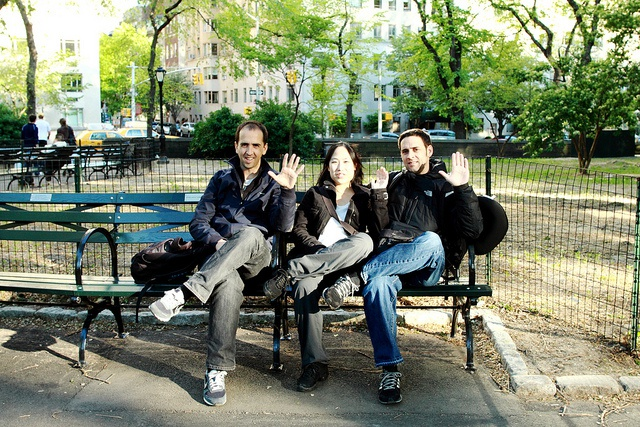Describe the objects in this image and their specific colors. I can see bench in darkgreen, black, darkgray, and teal tones, people in darkgreen, black, ivory, gray, and teal tones, people in darkgreen, black, gray, darkgray, and ivory tones, people in darkgreen, black, gray, ivory, and darkgray tones, and backpack in darkgreen, black, gray, and darkgray tones in this image. 